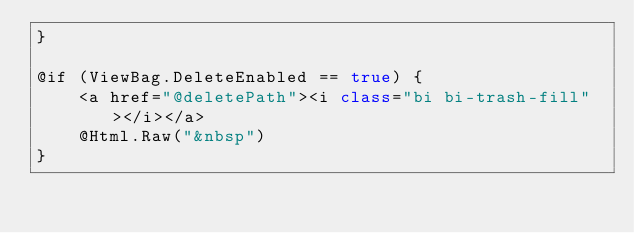<code> <loc_0><loc_0><loc_500><loc_500><_C#_>}

@if (ViewBag.DeleteEnabled == true) {
    <a href="@deletePath"><i class="bi bi-trash-fill"></i></a>
    @Html.Raw("&nbsp")
}
</code> 